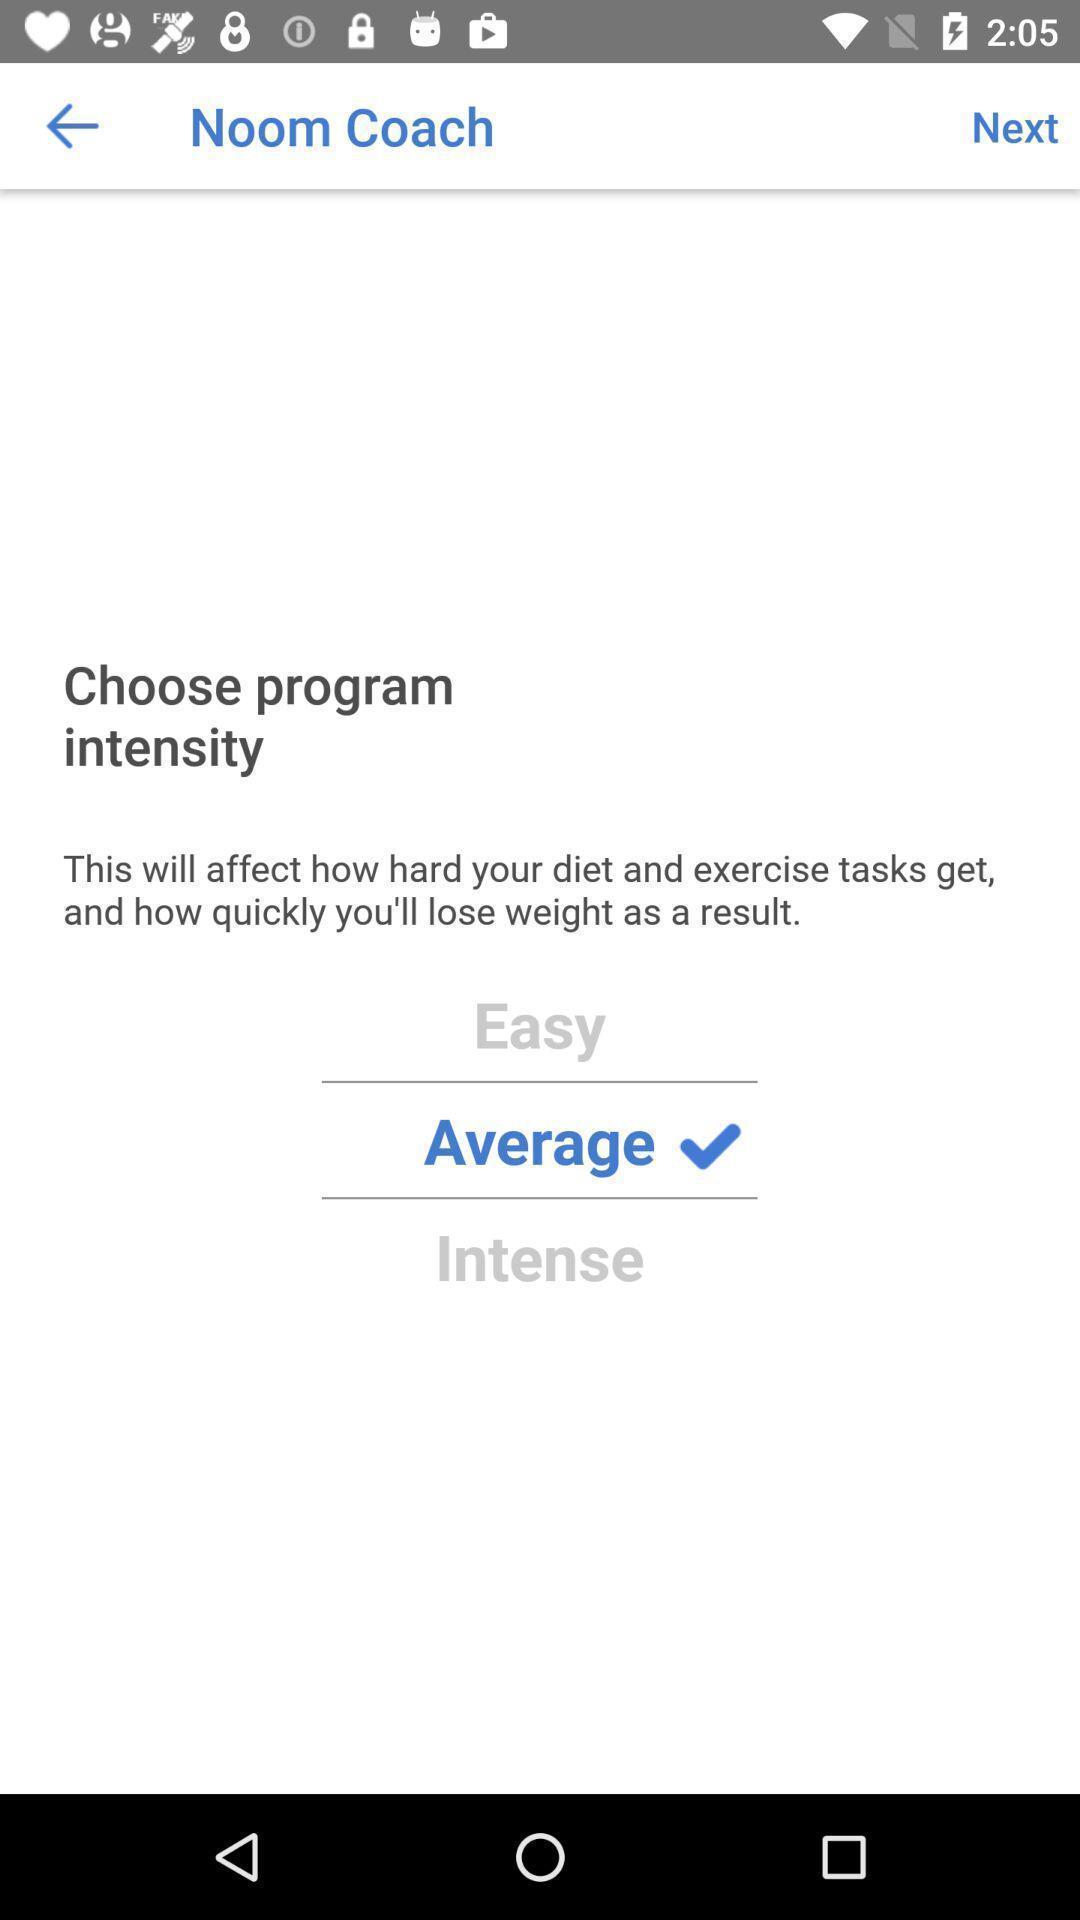Describe the key features of this screenshot. Page of a dieting app showing different options. 